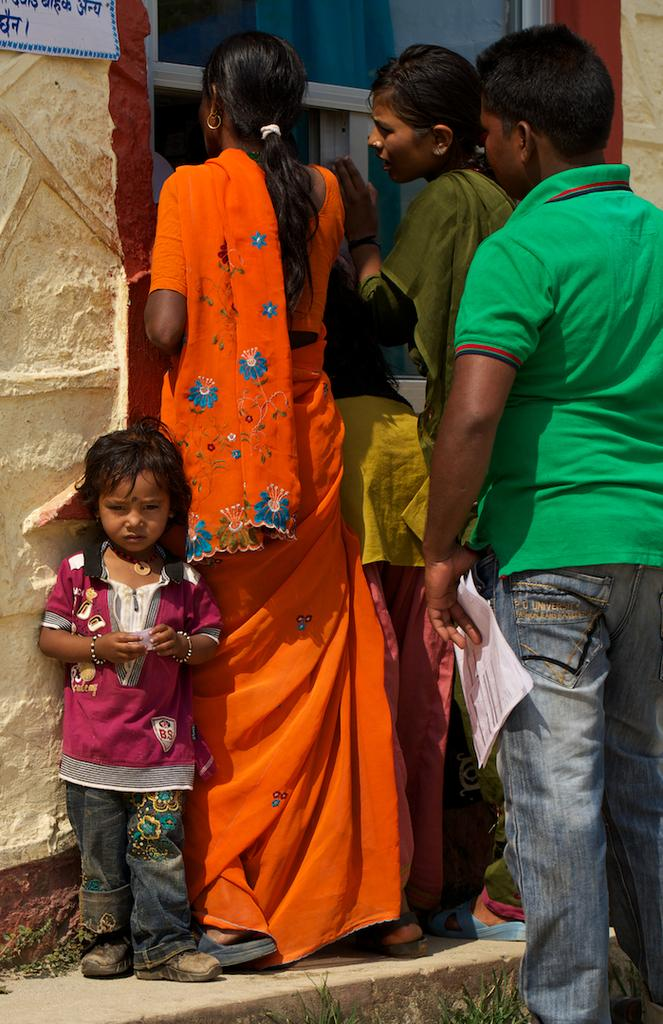Who can be seen in the image standing on the staircase? There are women, men, and a kid standing on a staircase in the image. What is on the left side of the image? There is a wall on the left side of the image. What is on the wall? There is a board on the wall. What can be seen at the top of the image? There appears to be a glass window at the top of the image. Can you tell me how many yaks are visible in the image? There are no yaks present in the image. What type of adjustment can be seen being made to the board on the wall? There is no adjustment being made to the board in the image. 